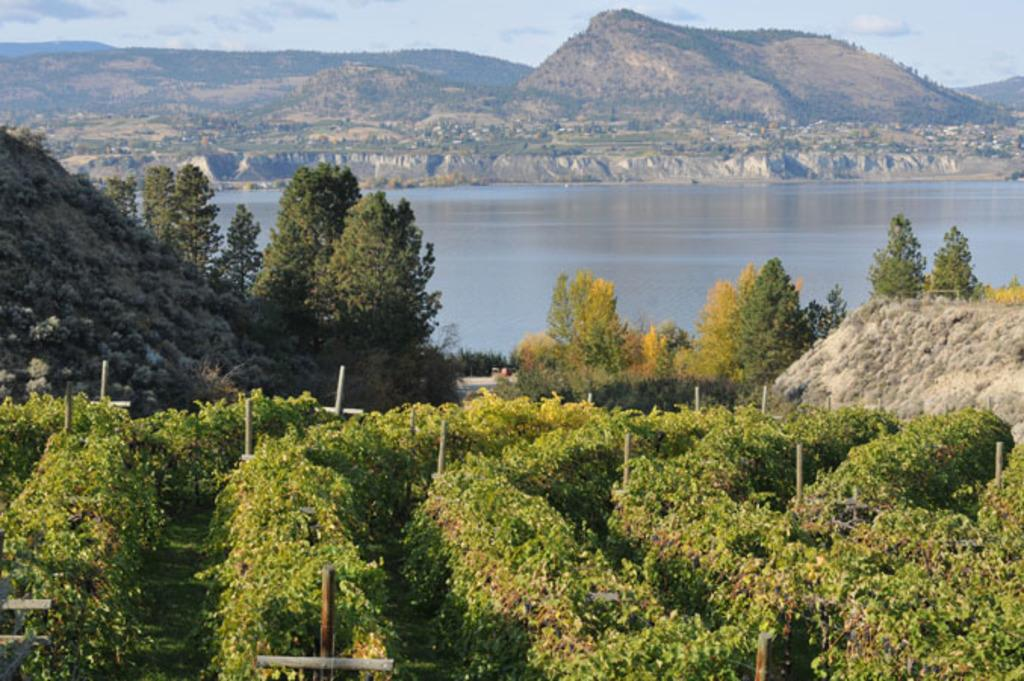What type of vegetation can be seen in the image? There are plants and trees visible in the image. What structures are present in the image? There are poles visible in the image. What natural feature can be seen in the image? There is a mountain in the image. What is the ground like in the image? There is ground visible in the image. What can be seen in the background of the image? The sky is visible in the background of the image, with clouds present. Can you tell me how many pigs are in the image? There are no pigs present in the image. What level of control does the beginner have over the mountain in the image? There is no indication of any control or interaction with the mountain in the image, and the concept of a beginner controlling a mountain is not applicable. 